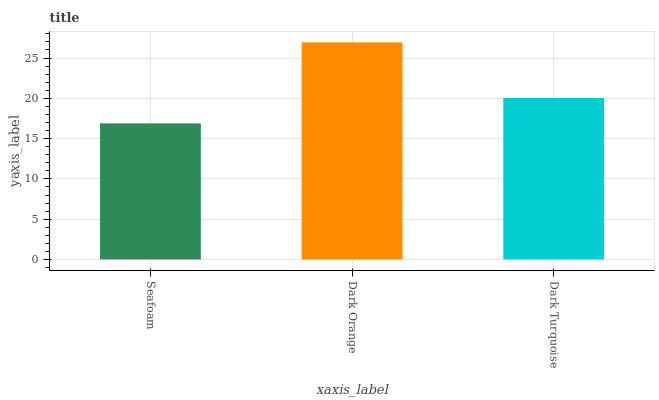Is Seafoam the minimum?
Answer yes or no. Yes. Is Dark Orange the maximum?
Answer yes or no. Yes. Is Dark Turquoise the minimum?
Answer yes or no. No. Is Dark Turquoise the maximum?
Answer yes or no. No. Is Dark Orange greater than Dark Turquoise?
Answer yes or no. Yes. Is Dark Turquoise less than Dark Orange?
Answer yes or no. Yes. Is Dark Turquoise greater than Dark Orange?
Answer yes or no. No. Is Dark Orange less than Dark Turquoise?
Answer yes or no. No. Is Dark Turquoise the high median?
Answer yes or no. Yes. Is Dark Turquoise the low median?
Answer yes or no. Yes. Is Dark Orange the high median?
Answer yes or no. No. Is Seafoam the low median?
Answer yes or no. No. 